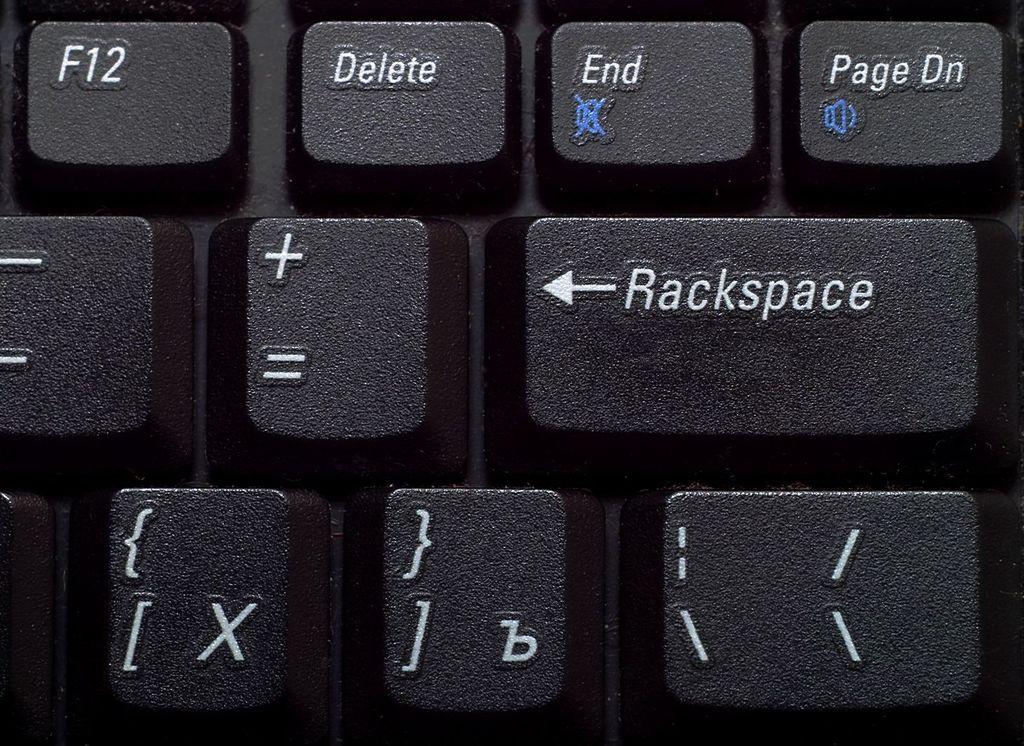What key had the blue speaker on it?
Keep it short and to the point. Page dn. Where is the f12 key?
Make the answer very short. Top left. 